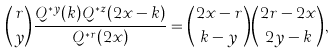Convert formula to latex. <formula><loc_0><loc_0><loc_500><loc_500>\binom { r } { y } \frac { Q ^ { * y } ( k ) Q ^ { * z } ( 2 x - k ) } { Q ^ { * r } ( 2 x ) } = \binom { 2 x - r } { k - y } \binom { 2 r - 2 x } { 2 y - k } ,</formula> 